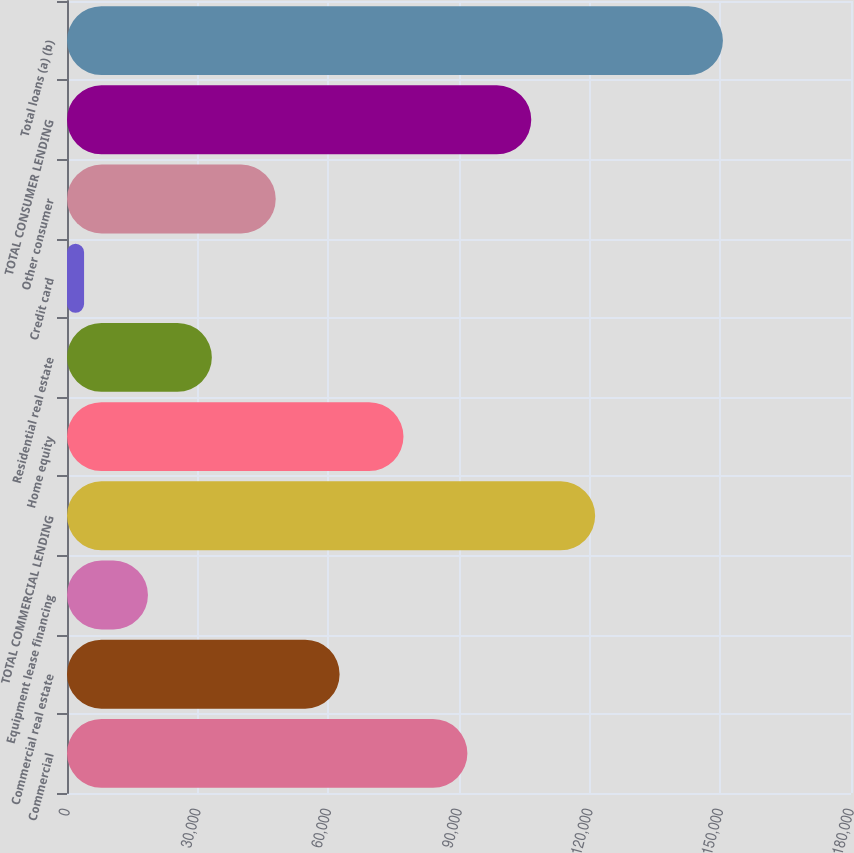Convert chart to OTSL. <chart><loc_0><loc_0><loc_500><loc_500><bar_chart><fcel>Commercial<fcel>Commercial real estate<fcel>Equipment lease financing<fcel>TOTAL COMMERCIAL LENDING<fcel>Home equity<fcel>Residential real estate<fcel>Credit card<fcel>Other consumer<fcel>TOTAL CONSUMER LENDING<fcel>Total loans (a) (b)<nl><fcel>91925<fcel>62590<fcel>18587.5<fcel>121260<fcel>77257.5<fcel>33255<fcel>3920<fcel>47922.5<fcel>106592<fcel>150595<nl></chart> 